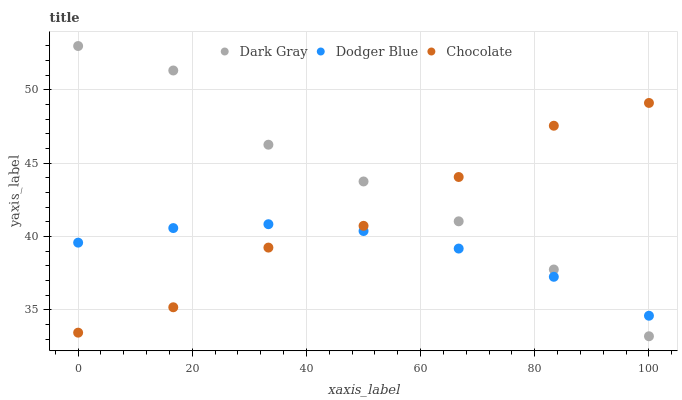Does Dodger Blue have the minimum area under the curve?
Answer yes or no. Yes. Does Dark Gray have the maximum area under the curve?
Answer yes or no. Yes. Does Chocolate have the minimum area under the curve?
Answer yes or no. No. Does Chocolate have the maximum area under the curve?
Answer yes or no. No. Is Dodger Blue the smoothest?
Answer yes or no. Yes. Is Chocolate the roughest?
Answer yes or no. Yes. Is Chocolate the smoothest?
Answer yes or no. No. Is Dodger Blue the roughest?
Answer yes or no. No. Does Dark Gray have the lowest value?
Answer yes or no. Yes. Does Chocolate have the lowest value?
Answer yes or no. No. Does Dark Gray have the highest value?
Answer yes or no. Yes. Does Chocolate have the highest value?
Answer yes or no. No. Does Chocolate intersect Dodger Blue?
Answer yes or no. Yes. Is Chocolate less than Dodger Blue?
Answer yes or no. No. Is Chocolate greater than Dodger Blue?
Answer yes or no. No. 